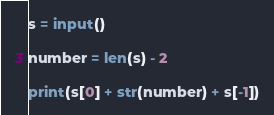Convert code to text. <code><loc_0><loc_0><loc_500><loc_500><_Python_>
s = input()

number = len(s) - 2

print(s[0] + str(number) + s[-1])
</code> 